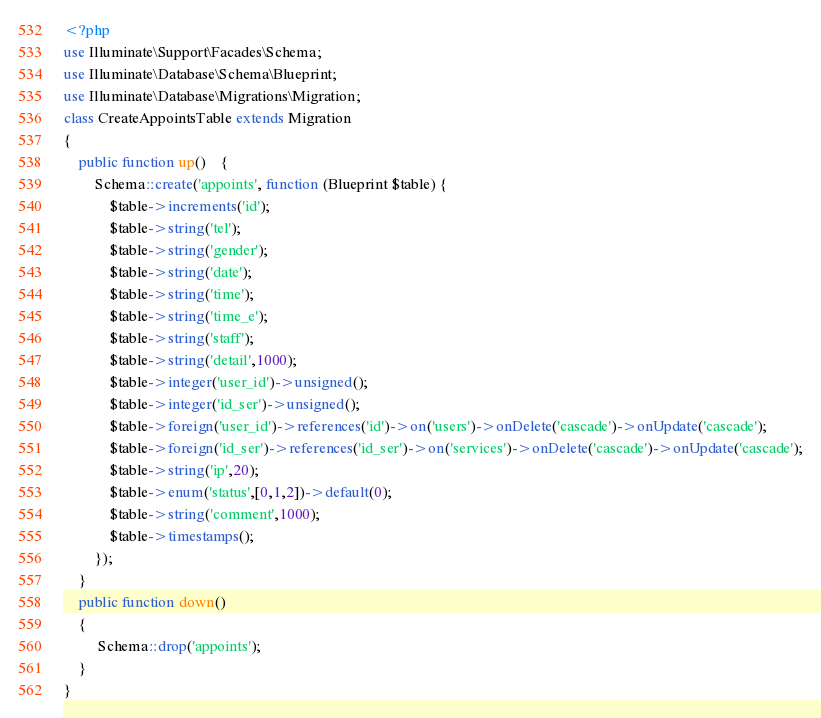Convert code to text. <code><loc_0><loc_0><loc_500><loc_500><_PHP_><?php
use Illuminate\Support\Facades\Schema;
use Illuminate\Database\Schema\Blueprint;
use Illuminate\Database\Migrations\Migration;
class CreateAppointsTable extends Migration
{
    public function up()    {
        Schema::create('appoints', function (Blueprint $table) {
            $table->increments('id');
            $table->string('tel');
            $table->string('gender');
            $table->string('date');
            $table->string('time');
            $table->string('time_e');
            $table->string('staff');
            $table->string('detail',1000);
            $table->integer('user_id')->unsigned();
            $table->integer('id_ser')->unsigned();
            $table->foreign('user_id')->references('id')->on('users')->onDelete('cascade')->onUpdate('cascade');
            $table->foreign('id_ser')->references('id_ser')->on('services')->onDelete('cascade')->onUpdate('cascade');
            $table->string('ip',20);
            $table->enum('status',[0,1,2])->default(0);
            $table->string('comment',1000);
            $table->timestamps();
        });
    }
    public function down()
    {
         Schema::drop('appoints');
    }
}</code> 